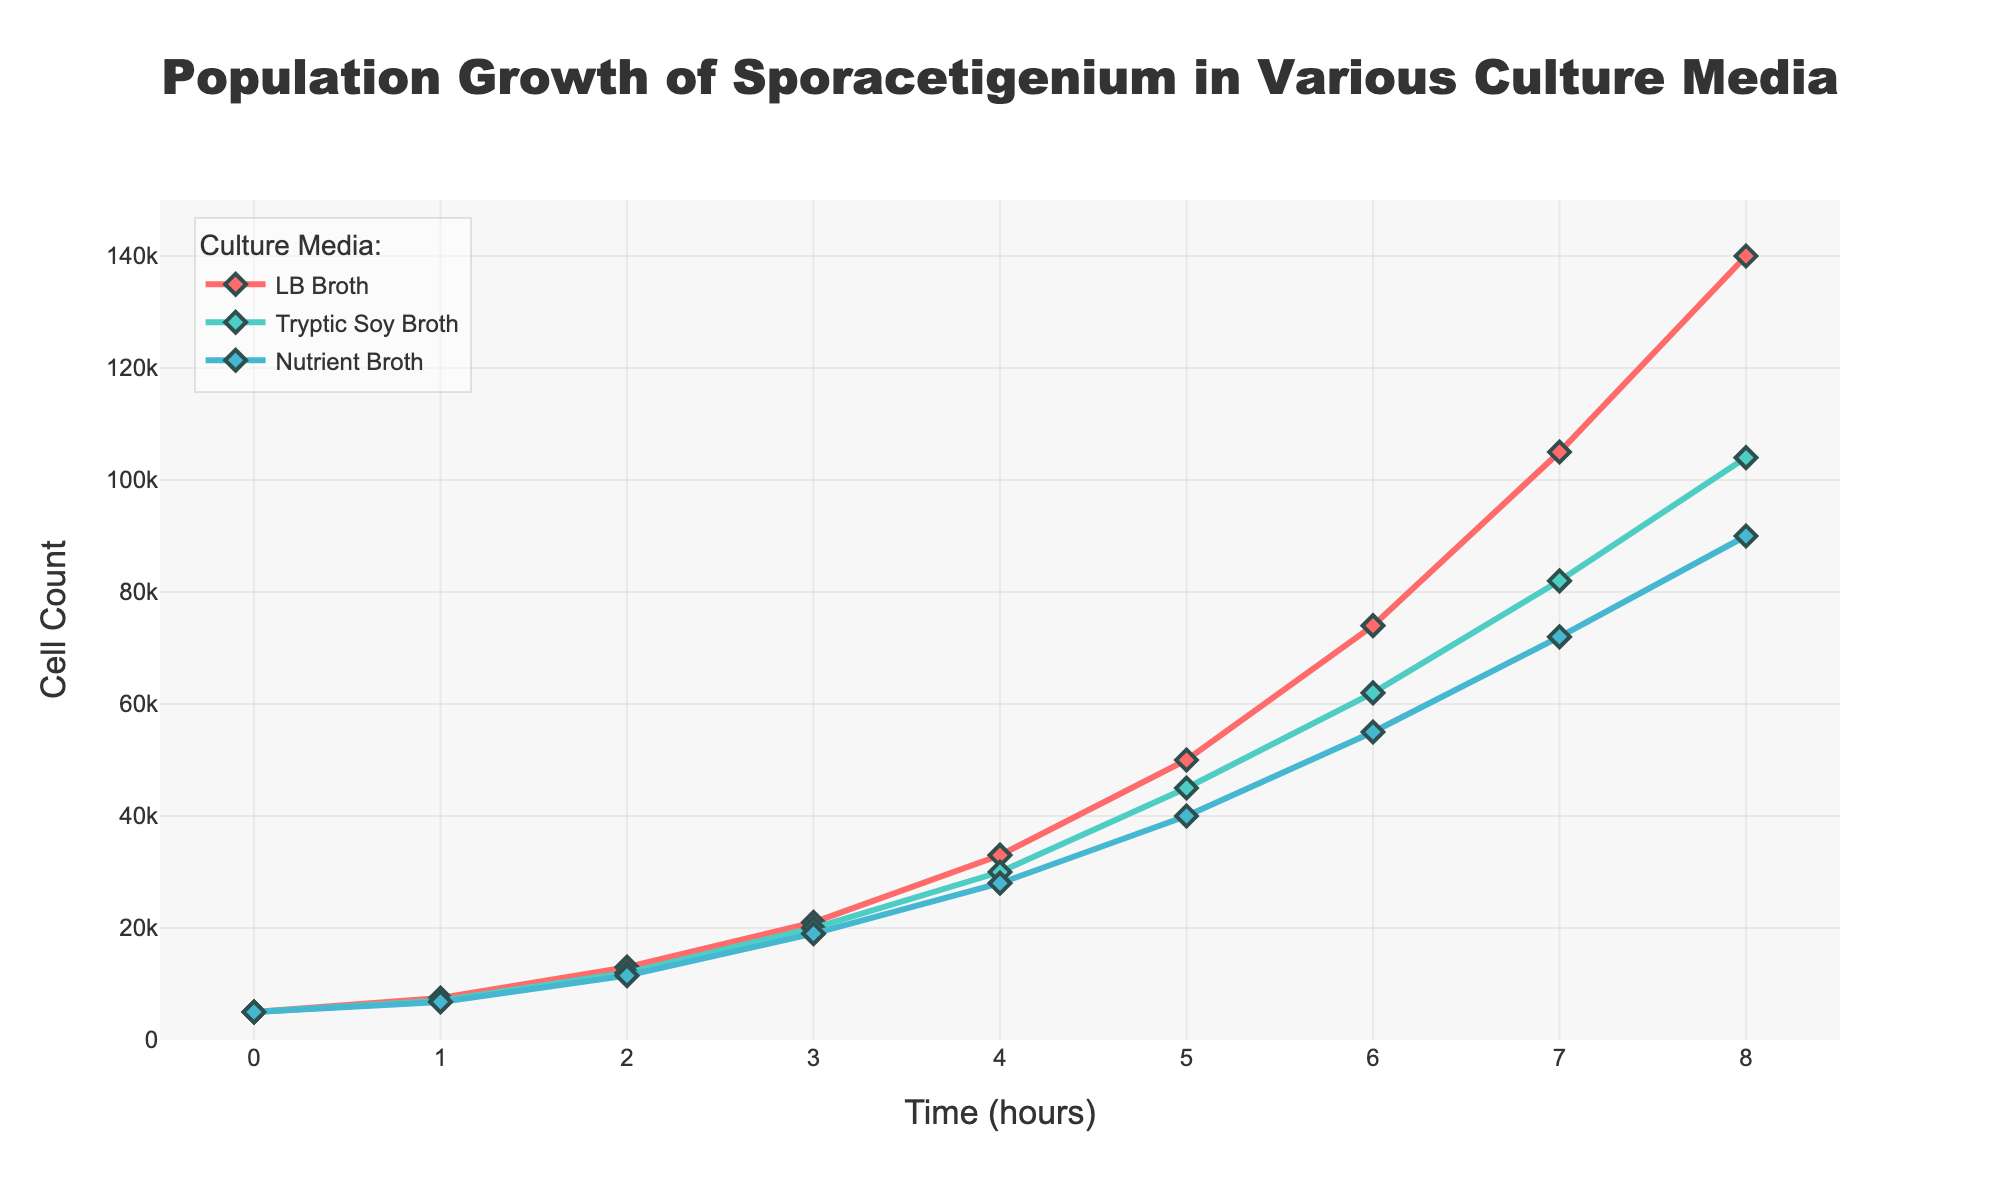What is the title of the figure? The title is located at the top of the figure and reads "Population Growth of Sporacetigenium in Various Culture Media".
Answer: Population Growth of Sporacetigenium in Various Culture Media What is the cell count at time 4 hours for LB Broth? Locate the LB Broth trace in the figure and find the y-axis value at the time value of 4 hours. The cell count is 33,000.
Answer: 33,000 Which culture media results in the highest cell count at any time point? By examining the three traces, LB Broth reaches the highest cell count of 140,000 at the 8-hour time point.
Answer: LB Broth What is the difference in cell count between Tryptic Soy Broth and Nutrient Broth at time 6 hours? Locate the points for both Tryptic Soy Broth and Nutrient Broth at 6 hours. Subtract 55,000 (Nutrient Broth) from 62,000 (Tryptic Soy Broth) to get 7,000.
Answer: 7,000 Does the cell count of Sporacetigenium in any of the culture media decrease over time? All traces show an increasing trend in cell count over time, so none of them display a decrease.
Answer: No At what time point does the cell count in LB Broth surpass 100,000? Locate when the LB Broth trace first crosses the 100,000 mark on the y-axis, which happens at 7 hours.
Answer: 7 hours How many data points represent the cell count in Nutrient Broth? Count the number of points used to plot the Nutrient Broth curve, which are displayed at each hour from 0 to 8.
Answer: 9 Compare the cell count trends among all three culture conditions. What can you conclude? All culture conditions show a similar pattern with exponential growth over time. However, LB Broth results in the highest growth rate, followed by Tryptic Soy Broth and then Nutrient Broth.
Answer: LB Broth > Tryptic Soy Broth > Nutrient Broth 